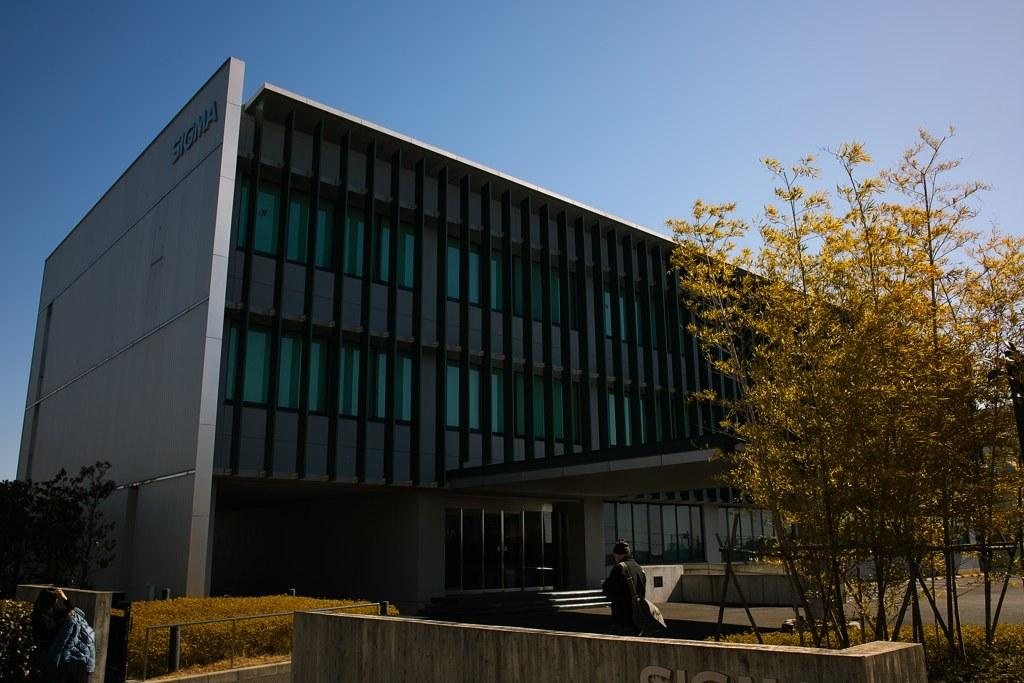What is the main structure in the center of the image? There is a building in the center of the image. What can be seen at the bottom of the image? People and trees are visible at the bottom of the image, as well as a shed. What is visible in the background of the image? The sky is visible in the background of the image. Can you hear a whistle being blown in the image? There is no indication of a whistle being blown in the image, as it is a still image and does not contain any sounds. 